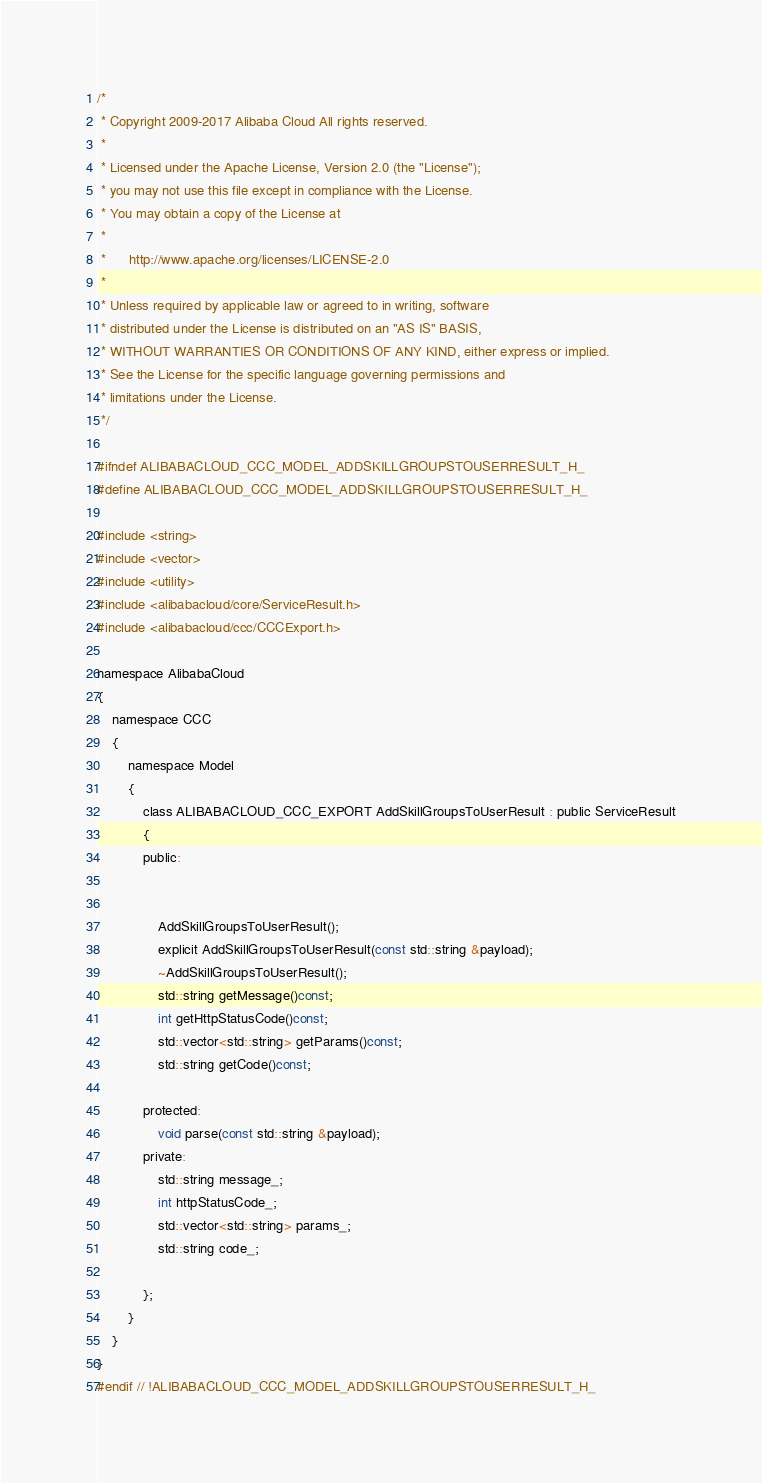<code> <loc_0><loc_0><loc_500><loc_500><_C_>/*
 * Copyright 2009-2017 Alibaba Cloud All rights reserved.
 * 
 * Licensed under the Apache License, Version 2.0 (the "License");
 * you may not use this file except in compliance with the License.
 * You may obtain a copy of the License at
 * 
 *      http://www.apache.org/licenses/LICENSE-2.0
 * 
 * Unless required by applicable law or agreed to in writing, software
 * distributed under the License is distributed on an "AS IS" BASIS,
 * WITHOUT WARRANTIES OR CONDITIONS OF ANY KIND, either express or implied.
 * See the License for the specific language governing permissions and
 * limitations under the License.
 */

#ifndef ALIBABACLOUD_CCC_MODEL_ADDSKILLGROUPSTOUSERRESULT_H_
#define ALIBABACLOUD_CCC_MODEL_ADDSKILLGROUPSTOUSERRESULT_H_

#include <string>
#include <vector>
#include <utility>
#include <alibabacloud/core/ServiceResult.h>
#include <alibabacloud/ccc/CCCExport.h>

namespace AlibabaCloud
{
	namespace CCC
	{
		namespace Model
		{
			class ALIBABACLOUD_CCC_EXPORT AddSkillGroupsToUserResult : public ServiceResult
			{
			public:


				AddSkillGroupsToUserResult();
				explicit AddSkillGroupsToUserResult(const std::string &payload);
				~AddSkillGroupsToUserResult();
				std::string getMessage()const;
				int getHttpStatusCode()const;
				std::vector<std::string> getParams()const;
				std::string getCode()const;

			protected:
				void parse(const std::string &payload);
			private:
				std::string message_;
				int httpStatusCode_;
				std::vector<std::string> params_;
				std::string code_;

			};
		}
	}
}
#endif // !ALIBABACLOUD_CCC_MODEL_ADDSKILLGROUPSTOUSERRESULT_H_</code> 